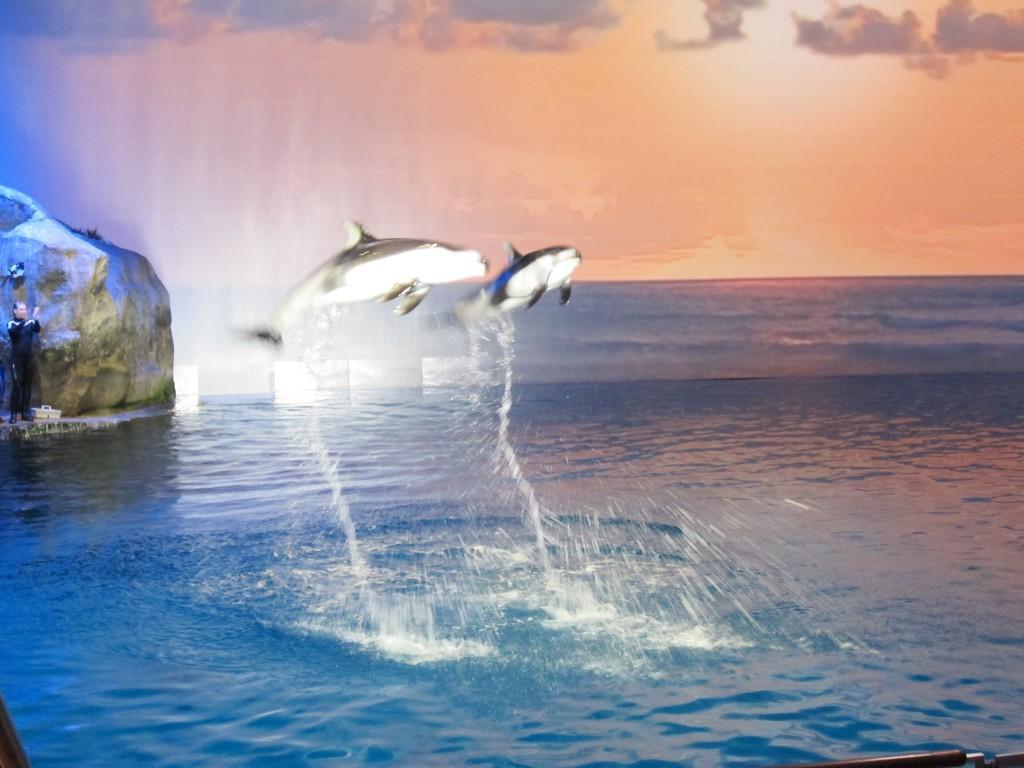Could you give a brief overview of what you see in this image? In this picture we can see a person, here we can see water, stone, fishes and we can see sky in the background. 